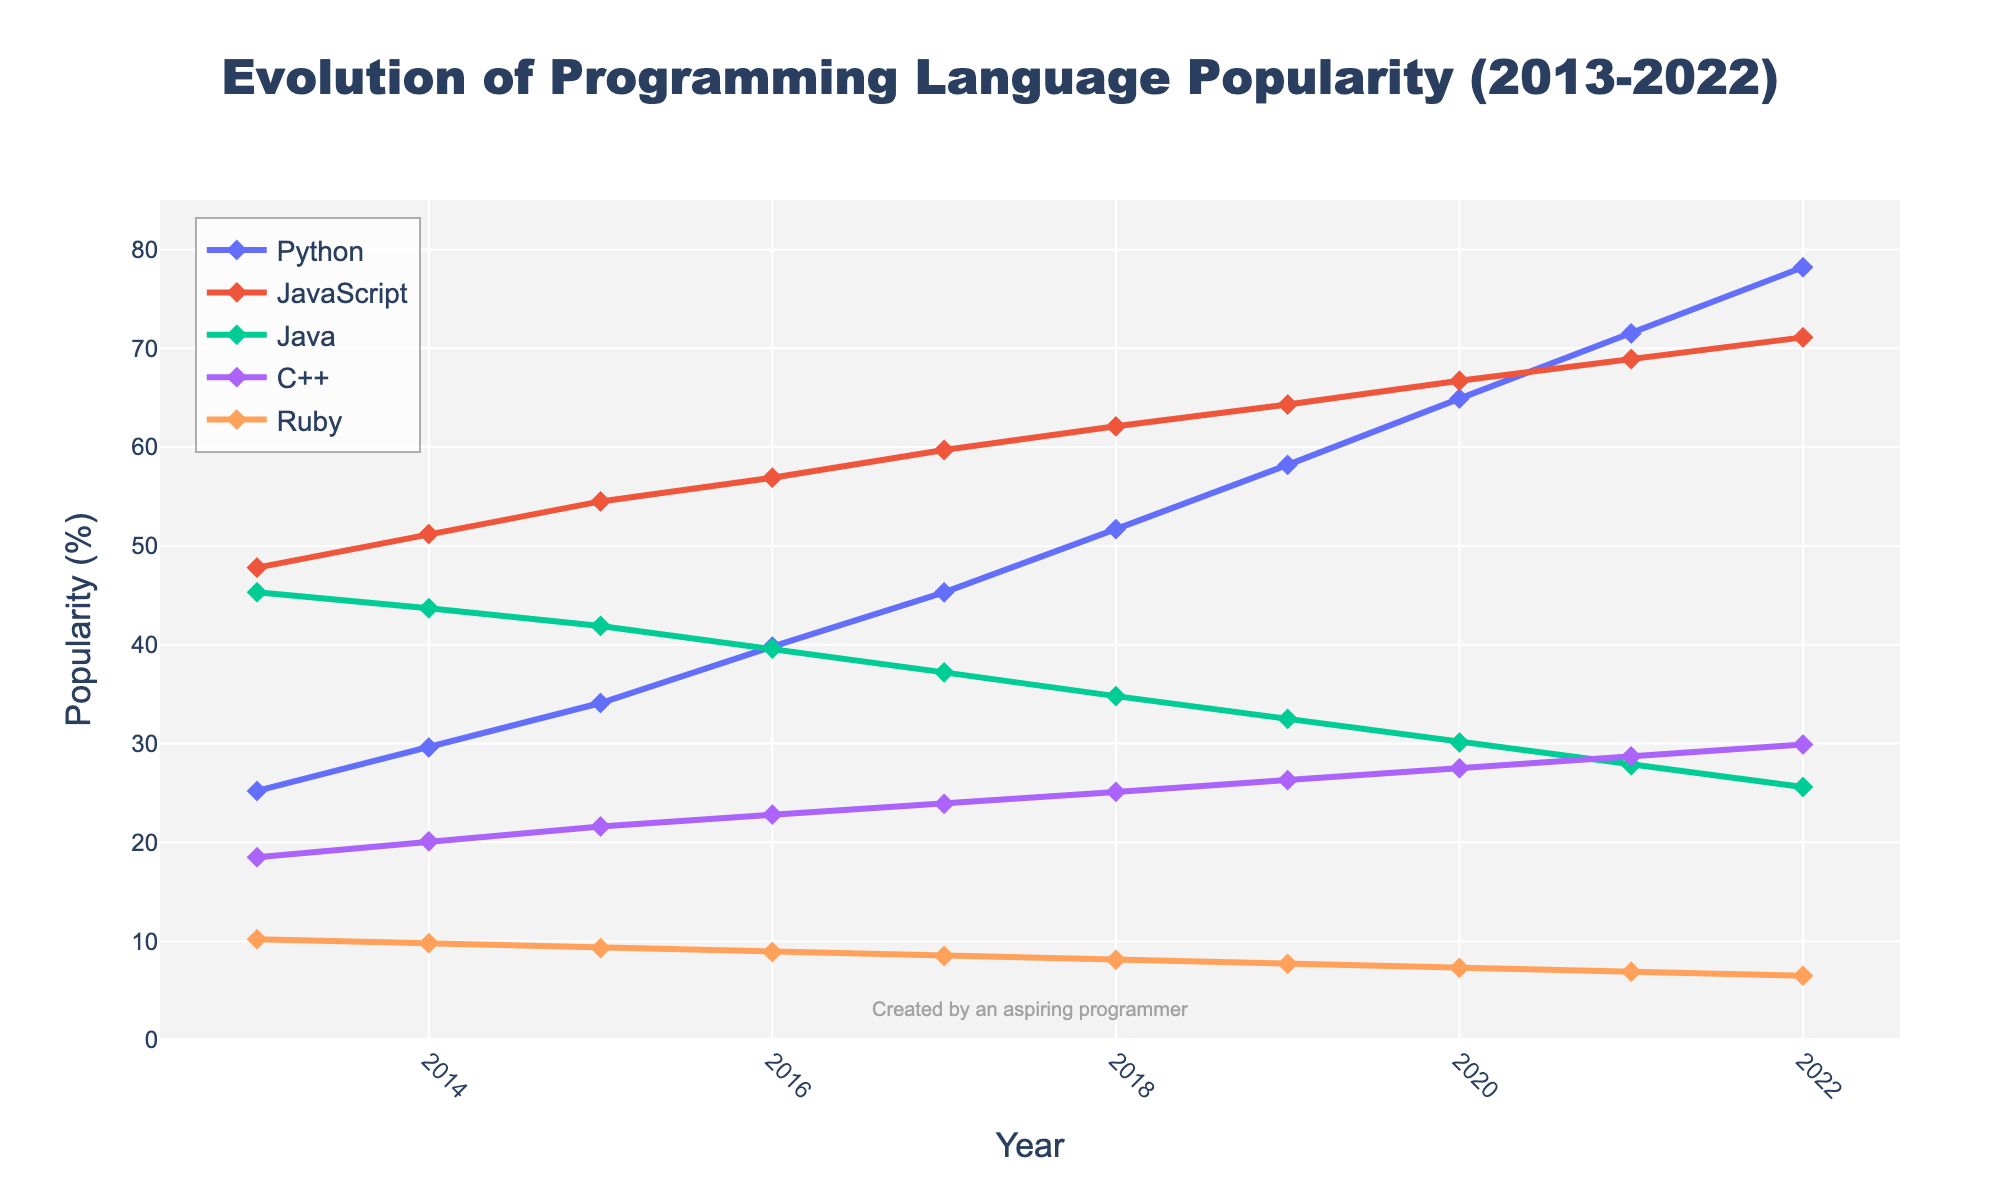What is the trend for Python's popularity from 2013 to 2022? The figure shows a steady increase in Python's popularity from 25.2% in 2013 to 78.2% in 2022. Each year, the line representing Python moves upward in the chart.
Answer: Steadily increasing Which programming language was more popular in 2016, Java or C++? By comparing the heights of the lines for Java and C++ in 2016, it is clear that Java had a higher popularity percentage (39.6%) compared to C++ (22.8%).
Answer: Java Was there any year when Ruby’s popularity increased compared to the previous year? If so, which year? By examining the Ruby line, we see that none of the years show an increase; the popularity of Ruby decreases gradually each year from 2013 to 2022.
Answer: No Compare the popularity of Python and Java in 2019. How much more popular was Python? In 2019, Python's popularity was 58.2% and Java's was 32.5%. The difference can be calculated as 58.2% - 32.5% = 25.7%.
Answer: 25.7% In which year did JavaScript first surpass 60% popularity? By examining the JavaScript line, it is evident that it first crossed the 60% mark in 2017, reaching 59.7% and in 2018, it was 62.1%.
Answer: 2018 Which language maintains the highest popularity throughout the period? The figure shows that JavaScript consistently has the highest popularity from 2013 to 2022.
Answer: JavaScript Calculate the average popularity of C++ over the decade. The sum of C++ popularity over the years (18.5 + 20.1 + 21.6 + 22.8 + 23.9 + 25.1 + 26.3 + 27.5 + 28.7 + 29.9) is 244.4. The average can be calculated as 244.4 / 10 = 24.44%.
Answer: 24.44% During which year did Python overtake Java in popularity? By closely following the lines for Python and Java, we see that Python overtakes Java in 2017, where Python is at 45.3% and Java is at 37.2%.
Answer: 2017 